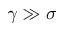Convert formula to latex. <formula><loc_0><loc_0><loc_500><loc_500>\gamma \gg \sigma</formula> 